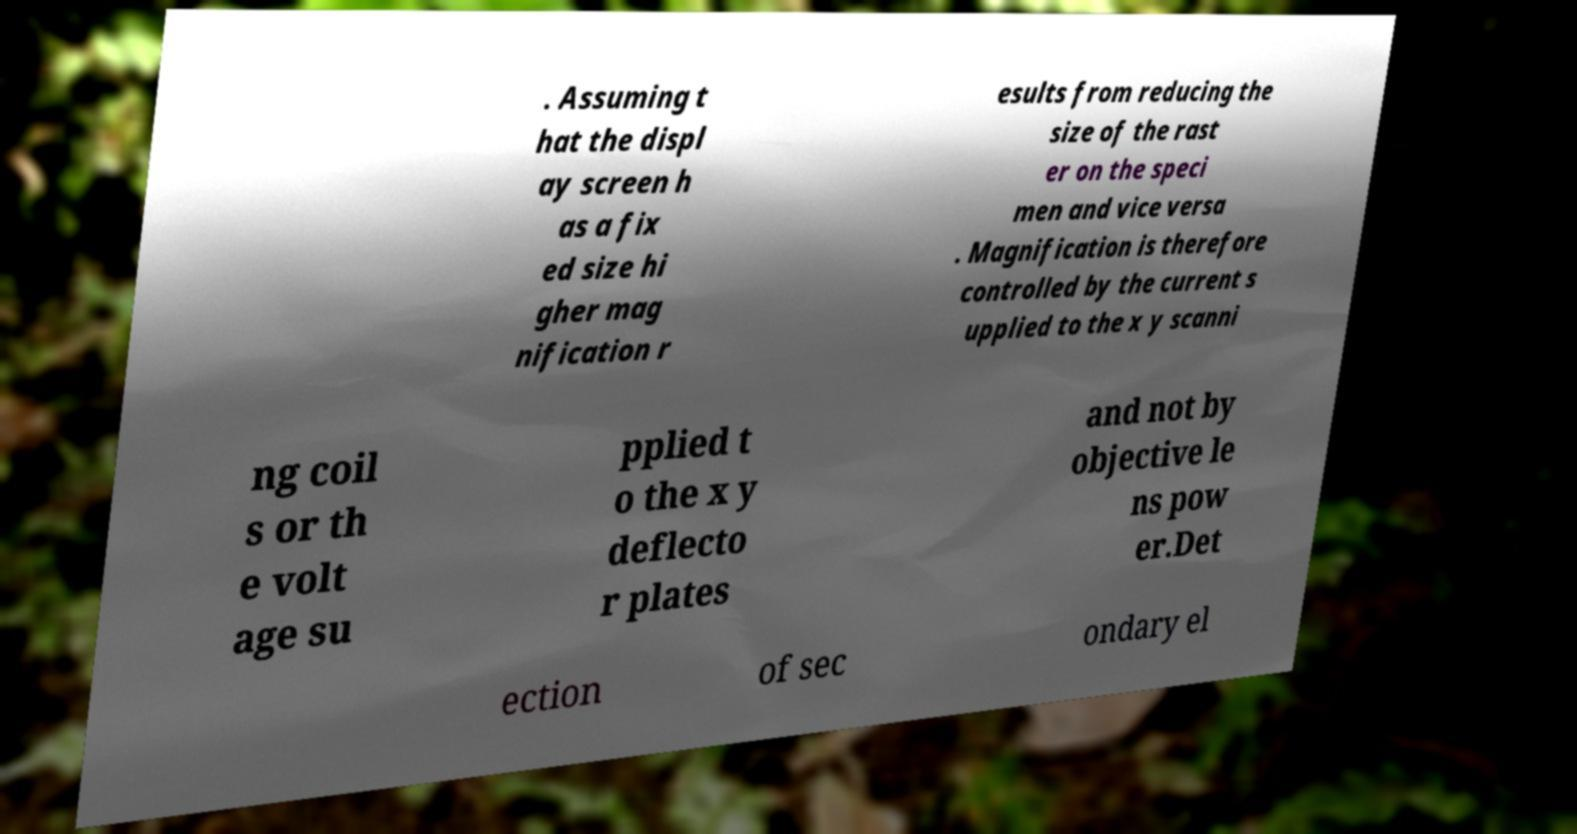For documentation purposes, I need the text within this image transcribed. Could you provide that? . Assuming t hat the displ ay screen h as a fix ed size hi gher mag nification r esults from reducing the size of the rast er on the speci men and vice versa . Magnification is therefore controlled by the current s upplied to the x y scanni ng coil s or th e volt age su pplied t o the x y deflecto r plates and not by objective le ns pow er.Det ection of sec ondary el 